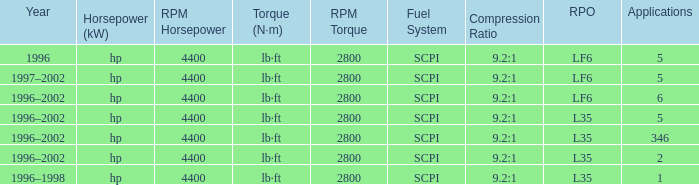What are the torque characteristics of the model with 346 applications? Lb·ft (n·m) at 2,800rpm. 